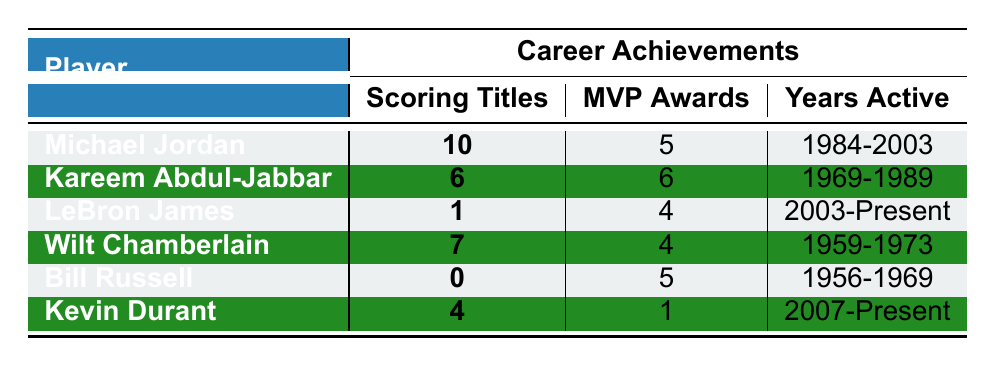What is the total number of MVP awards won by Michael Jordan and Kareem Abdul-Jabbar combined? Michael Jordan has 5 MVP awards, and Kareem Abdul-Jabbar has 6 MVP awards. Adding these together gives us 5 + 6 = 11 MVP awards in total.
Answer: 11 Which player has the most scoring titles? Michael Jordan has the most scoring titles with a total of 10 titles, as seen in the table.
Answer: Michael Jordan Is it true that Wilt Chamberlain won more MVP awards than LeBron James? Wilt Chamberlain won 4 MVP awards, and LeBron James won 4 MVP awards as well. Since they are equal, the statement is false.
Answer: No How many players in the table have won exactly 4 MVP awards? The table shows that Kareem Abdul-Jabbar and LeBron James both have 4 MVP awards. Therefore, there are 2 players with exactly 4 MVP awards.
Answer: 2 What is the average number of scoring titles among all the players listed? The total number of scoring titles is 10 (Jordan) + 6 (Abdul-Jabbar) + 1 (James) + 7 (Chamberlain) + 0 (Russell) + 4 (Durant) = 28. There are 6 players, so the average is 28/6 ≈ 4.67.
Answer: 4.67 Did any player win a scoring title without winning an MVP award? Yes, Kevin Durant won 4 scoring titles but only has 1 MVP award, indicating he won scoring titles without earning multiple MVPs.
Answer: Yes Who has more MVP awards, Bill Russell or Kevin Durant? Bill Russell has 5 MVP awards while Kevin Durant has 1 MVP award. Since 5 is greater than 1, Bill Russell has more MVP awards.
Answer: Bill Russell What percentage of scoring titles does Michael Jordan represent among all listed players? Michael Jordan has 10 scoring titles, and the total is 28. The calculation is (10/28) * 100 ≈ 35.71%.
Answer: 35.71% 